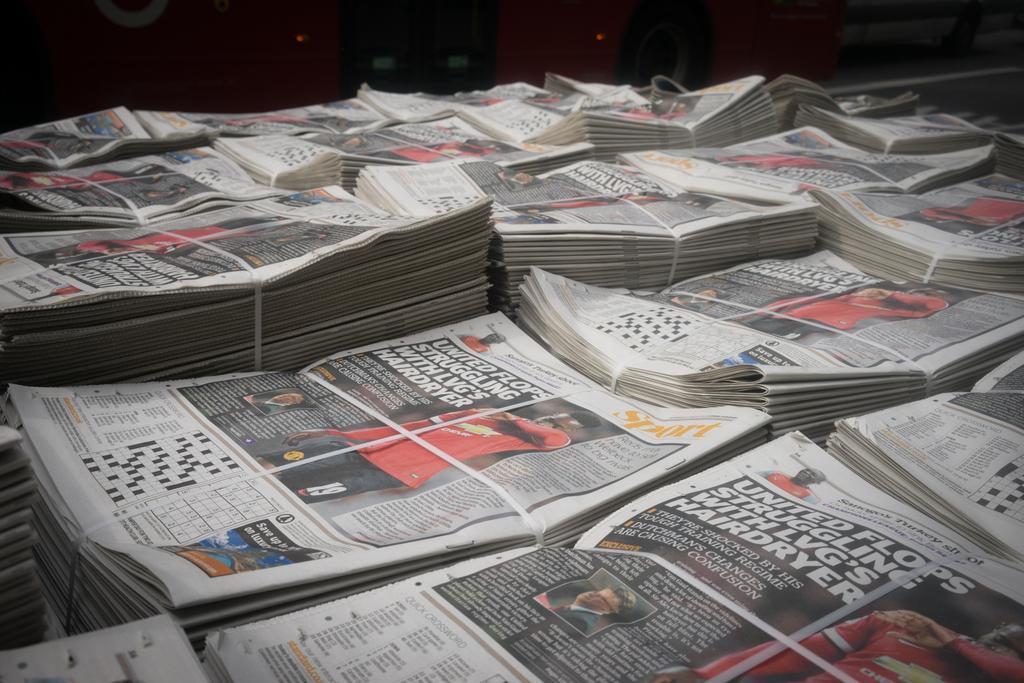Can you describe this image briefly? In this picture we can see newspaper bundles and in the background we can see some objects. 